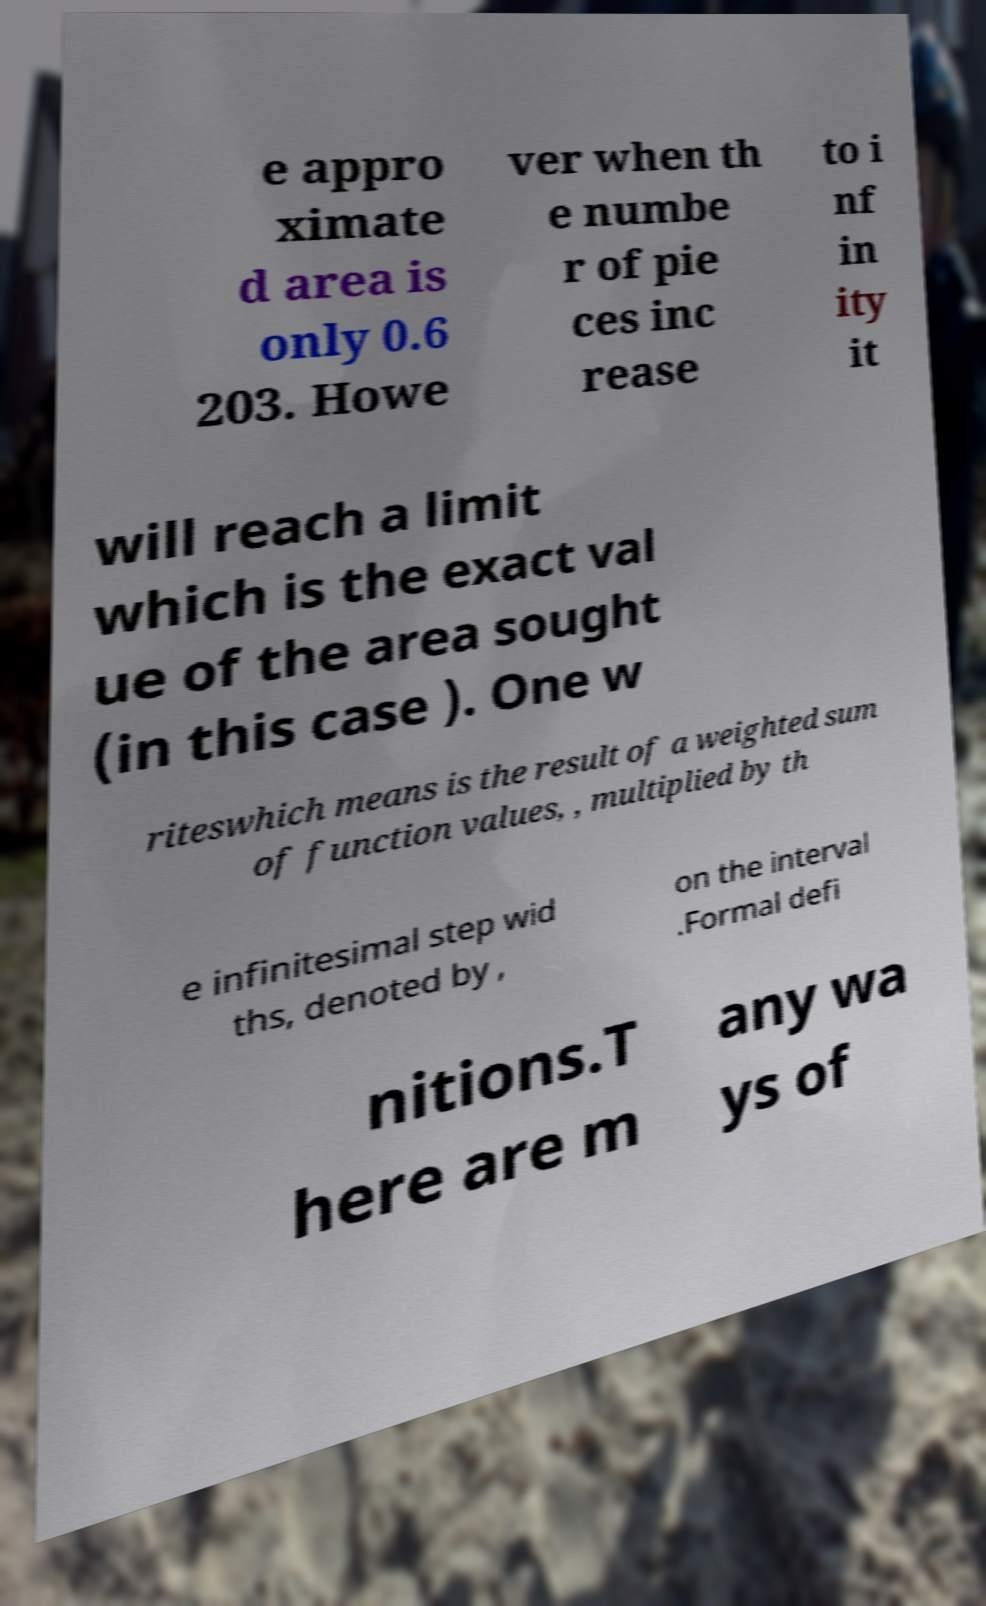What messages or text are displayed in this image? I need them in a readable, typed format. e appro ximate d area is only 0.6 203. Howe ver when th e numbe r of pie ces inc rease to i nf in ity it will reach a limit which is the exact val ue of the area sought (in this case ). One w riteswhich means is the result of a weighted sum of function values, , multiplied by th e infinitesimal step wid ths, denoted by , on the interval .Formal defi nitions.T here are m any wa ys of 